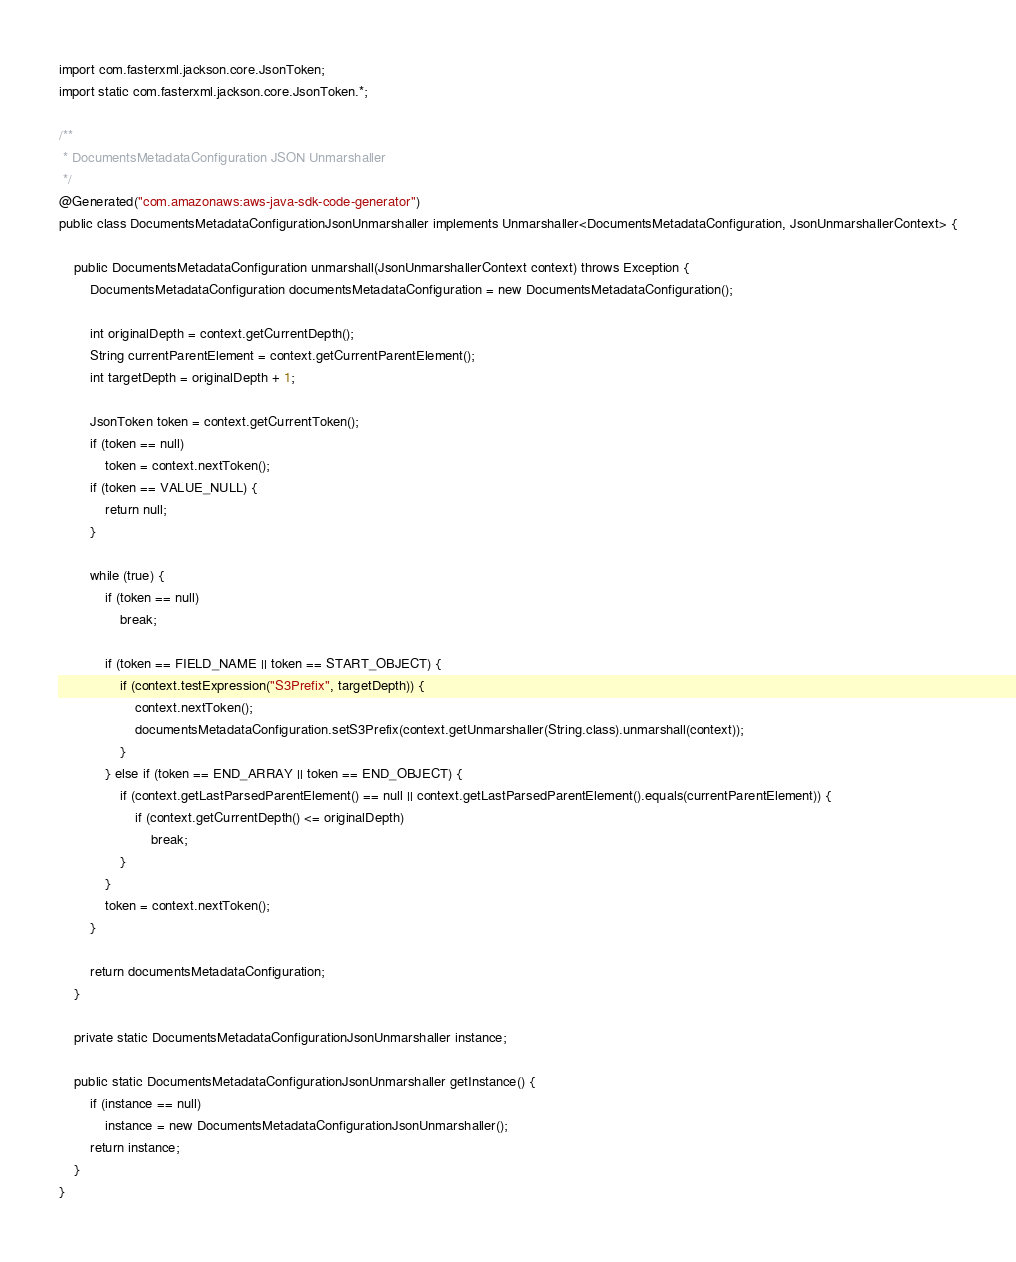Convert code to text. <code><loc_0><loc_0><loc_500><loc_500><_Java_>
import com.fasterxml.jackson.core.JsonToken;
import static com.fasterxml.jackson.core.JsonToken.*;

/**
 * DocumentsMetadataConfiguration JSON Unmarshaller
 */
@Generated("com.amazonaws:aws-java-sdk-code-generator")
public class DocumentsMetadataConfigurationJsonUnmarshaller implements Unmarshaller<DocumentsMetadataConfiguration, JsonUnmarshallerContext> {

    public DocumentsMetadataConfiguration unmarshall(JsonUnmarshallerContext context) throws Exception {
        DocumentsMetadataConfiguration documentsMetadataConfiguration = new DocumentsMetadataConfiguration();

        int originalDepth = context.getCurrentDepth();
        String currentParentElement = context.getCurrentParentElement();
        int targetDepth = originalDepth + 1;

        JsonToken token = context.getCurrentToken();
        if (token == null)
            token = context.nextToken();
        if (token == VALUE_NULL) {
            return null;
        }

        while (true) {
            if (token == null)
                break;

            if (token == FIELD_NAME || token == START_OBJECT) {
                if (context.testExpression("S3Prefix", targetDepth)) {
                    context.nextToken();
                    documentsMetadataConfiguration.setS3Prefix(context.getUnmarshaller(String.class).unmarshall(context));
                }
            } else if (token == END_ARRAY || token == END_OBJECT) {
                if (context.getLastParsedParentElement() == null || context.getLastParsedParentElement().equals(currentParentElement)) {
                    if (context.getCurrentDepth() <= originalDepth)
                        break;
                }
            }
            token = context.nextToken();
        }

        return documentsMetadataConfiguration;
    }

    private static DocumentsMetadataConfigurationJsonUnmarshaller instance;

    public static DocumentsMetadataConfigurationJsonUnmarshaller getInstance() {
        if (instance == null)
            instance = new DocumentsMetadataConfigurationJsonUnmarshaller();
        return instance;
    }
}
</code> 